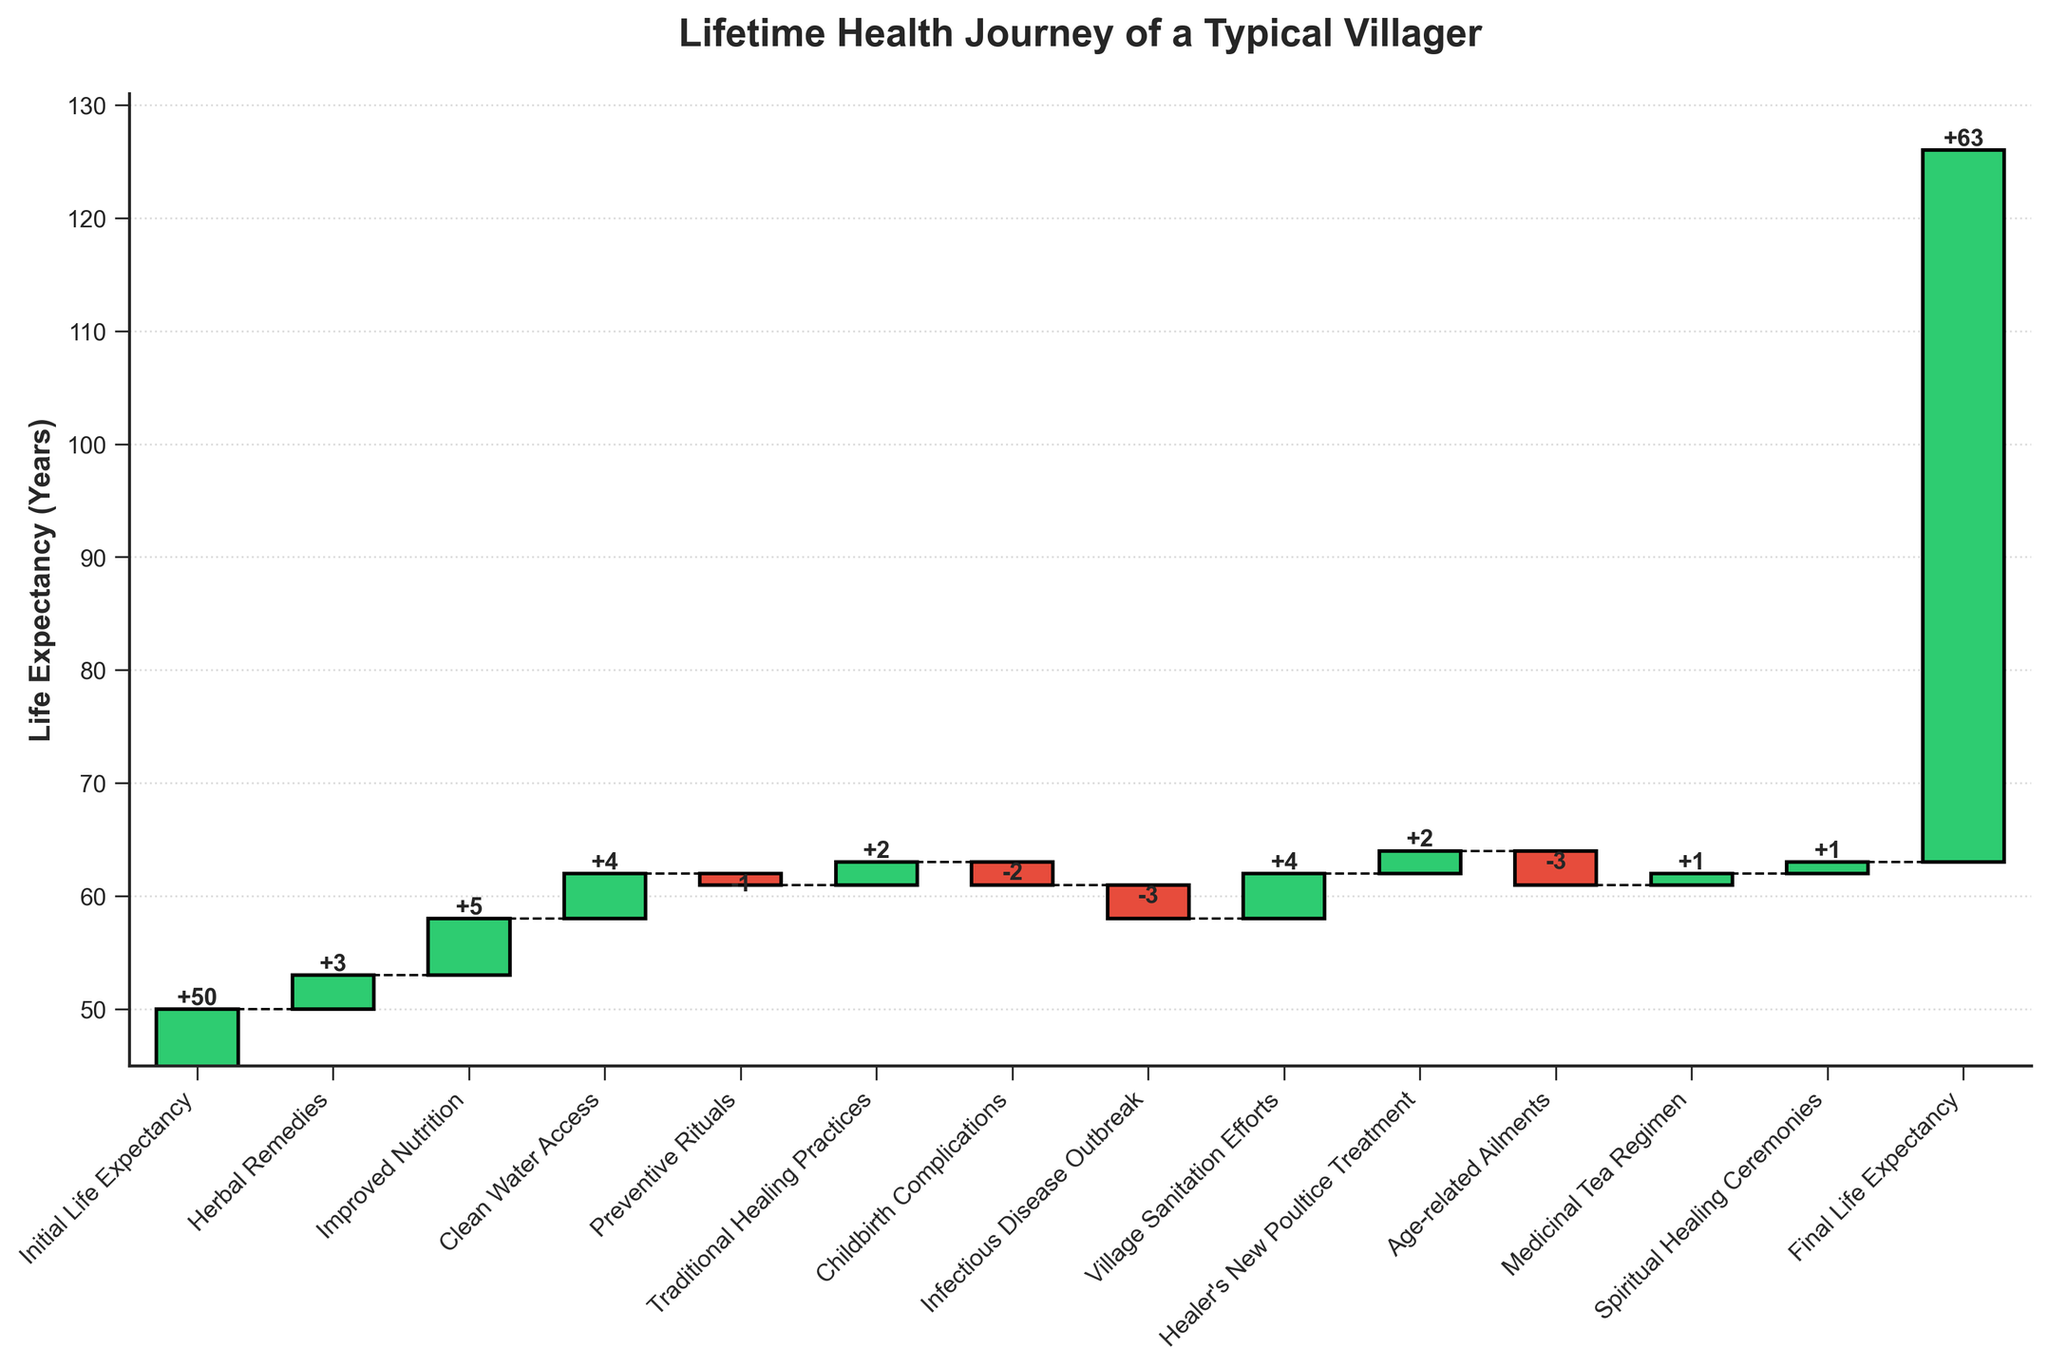what is the initial life expectancy shown in the chart? The initial life expectancy is indicated at the start of the chart, which is clearly labeled as "Initial Life Expectancy". The corresponding value is shown as 50 years.
Answer: 50 years What's the total increase in life expectancy due to all positive impacts? Add all positive impacts: Herbal Remedies (+3), Improved Nutrition (+5), Clean Water Access (+4), Traditional Healing Practices (+2), Village Sanitation Efforts (+4), Healer's New Poultice Treatment (+2), Medicinal Tea Regimen (+1), and Spiritual Healing Ceremonies (+1). Sum = 3 + 5 + 4 + 2 + 4 + 2 + 1 + 1 = 22 years.
Answer: 22 years How much did childbirth complications and infectious disease outbreak reduce life expectancy combined? Childbirth Complications reduced by -2 years and Infectious Disease Outbreak reduced by -3 years. Combined reduction = -2 + (-3) = -5 years.
Answer: -5 years Which category has the most significant positive impact on life expectancy? Compare the positive impacts of all categories: Herbal Remedies (+3), Improved Nutrition (+5), Clean Water Access (+4), Traditional Healing Practices (+2), Village Sanitation Efforts (+4), Healer's New Poultice Treatment (+2), Medicinal Tea Regimen (+1), and Spiritual Healing Ceremonies (+1). The largest value among them is Improved Nutrition (+5).
Answer: Improved Nutrition How does the final life expectancy compare to the initial life expectancy? The initial life expectancy is 50 years, and the final life expectancy is 63 years. Compare these two values: 63 - 50 = 13 years increase.
Answer: 13 years increase What is the net change in life expectancy due to preventive rituals and age-related ailments? Preventive rituals have an impact of -1 year, and age-related ailments have an impact of -3 years. Net change = -1 + (-3) = -4 years.
Answer: -4 years How many categories had a negative impact on life expectancy? Identify the categories with negative impacts: Preventive Rituals (-1), Childbirth Complications (-2), Infectious Disease Outbreak (-3), and Age-related Ailments (-3). There are 4 such categories.
Answer: 4 categories What was the cumulative life expectancy after the village sanitation efforts? Starting from the initial life expectancy of 50, add the impacts up to and including Village Sanitation Efforts. Cumulative sum: 50 + 3 + 5 + 4 - 1 + 2 - 2 - 3 + 4 = 62.
Answer: 62 years How does the life expectancy change after the introduction of the healer's new poultice treatment? Before the Healer's New Poultice Treatment, the cumulative life expectancy was 62 years. The poultice treatment added +2 years, so the new life expectancy becomes 62 + 2 = 64 (Note: the cumulative effect up to the final value seems incorrect in data but calculation follows sum steps).
Answer: Increases by 2 years 